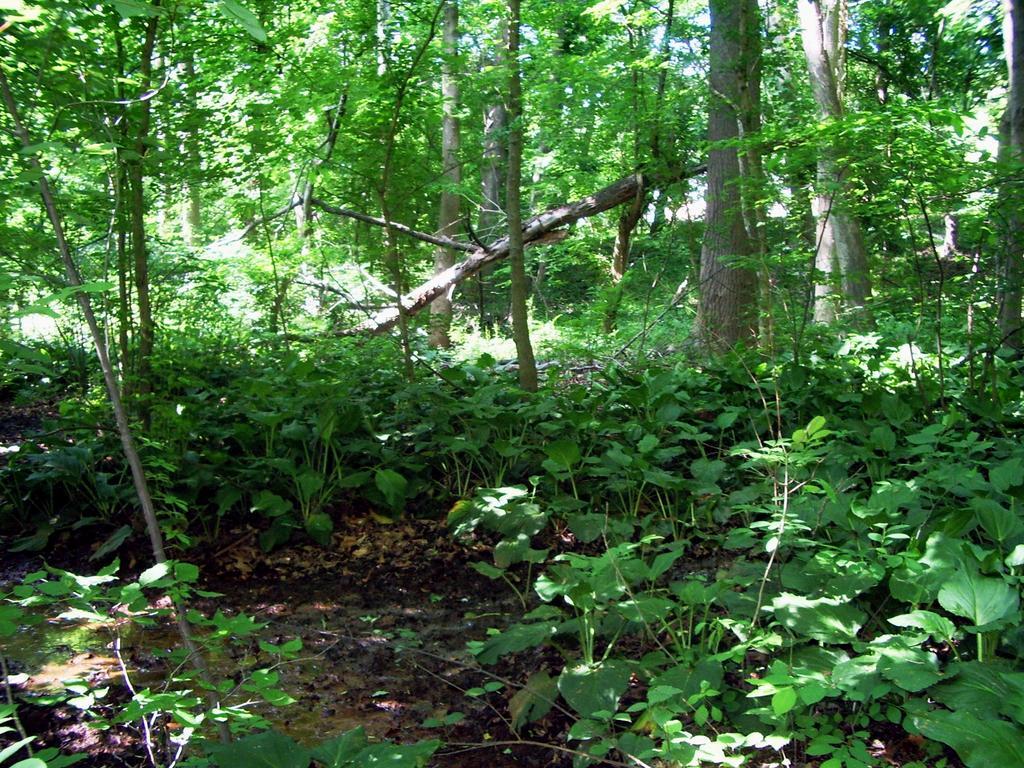Describe this image in one or two sentences. In the given picture, we can see a few plants included with the trees. 